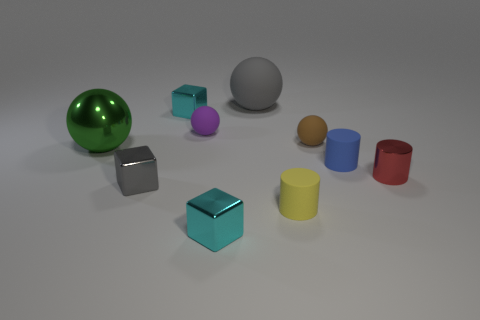Subtract all cyan blocks. How many blocks are left? 1 Subtract all brown spheres. How many spheres are left? 3 Subtract all balls. How many objects are left? 6 Subtract all cyan balls. Subtract all red cubes. How many balls are left? 4 Subtract all purple blocks. How many blue cylinders are left? 1 Subtract all big green cylinders. Subtract all small brown matte balls. How many objects are left? 9 Add 3 blue cylinders. How many blue cylinders are left? 4 Add 4 tiny blue rubber cylinders. How many tiny blue rubber cylinders exist? 5 Subtract 0 purple cubes. How many objects are left? 10 Subtract 2 cylinders. How many cylinders are left? 1 